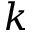<formula> <loc_0><loc_0><loc_500><loc_500>k</formula> 